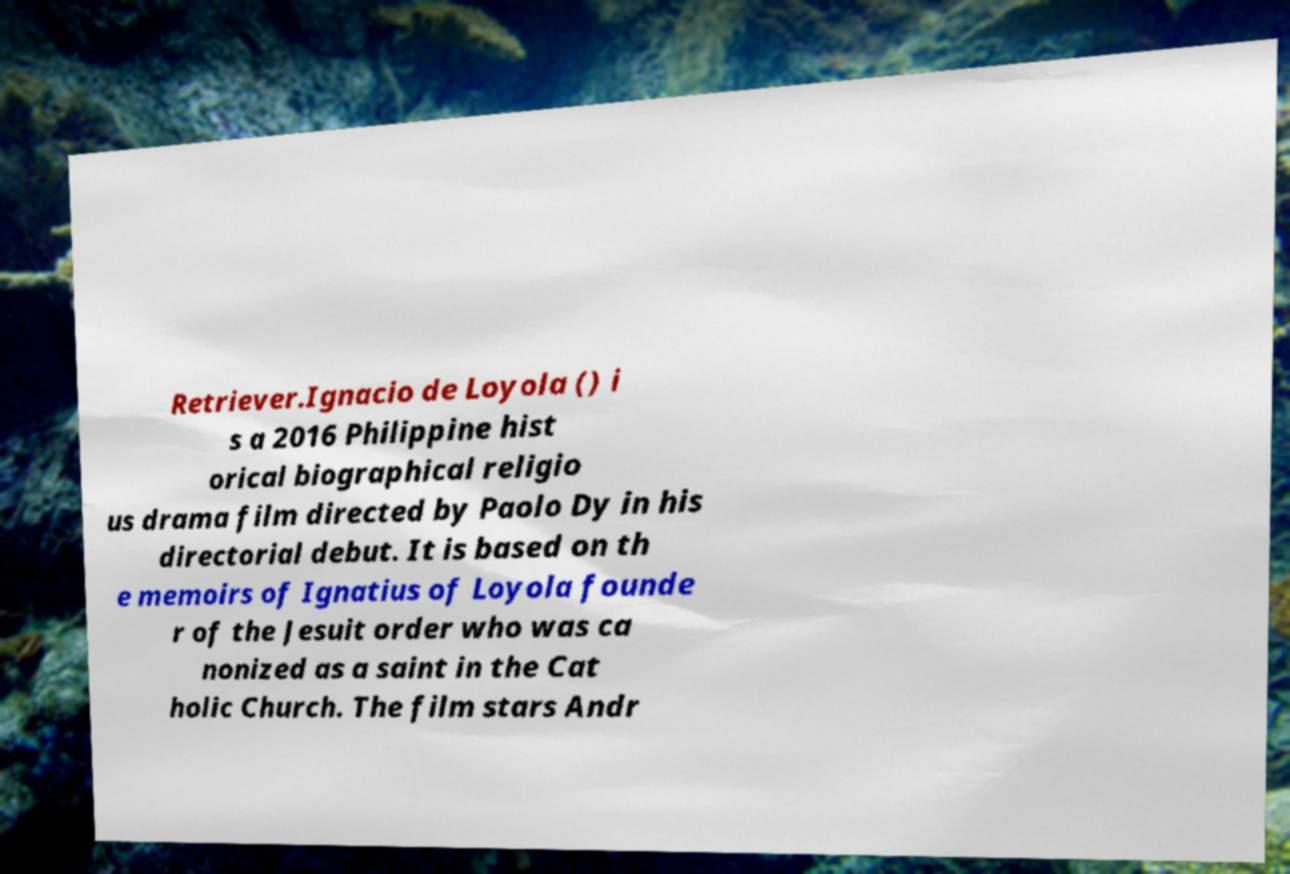Could you assist in decoding the text presented in this image and type it out clearly? Retriever.Ignacio de Loyola () i s a 2016 Philippine hist orical biographical religio us drama film directed by Paolo Dy in his directorial debut. It is based on th e memoirs of Ignatius of Loyola founde r of the Jesuit order who was ca nonized as a saint in the Cat holic Church. The film stars Andr 